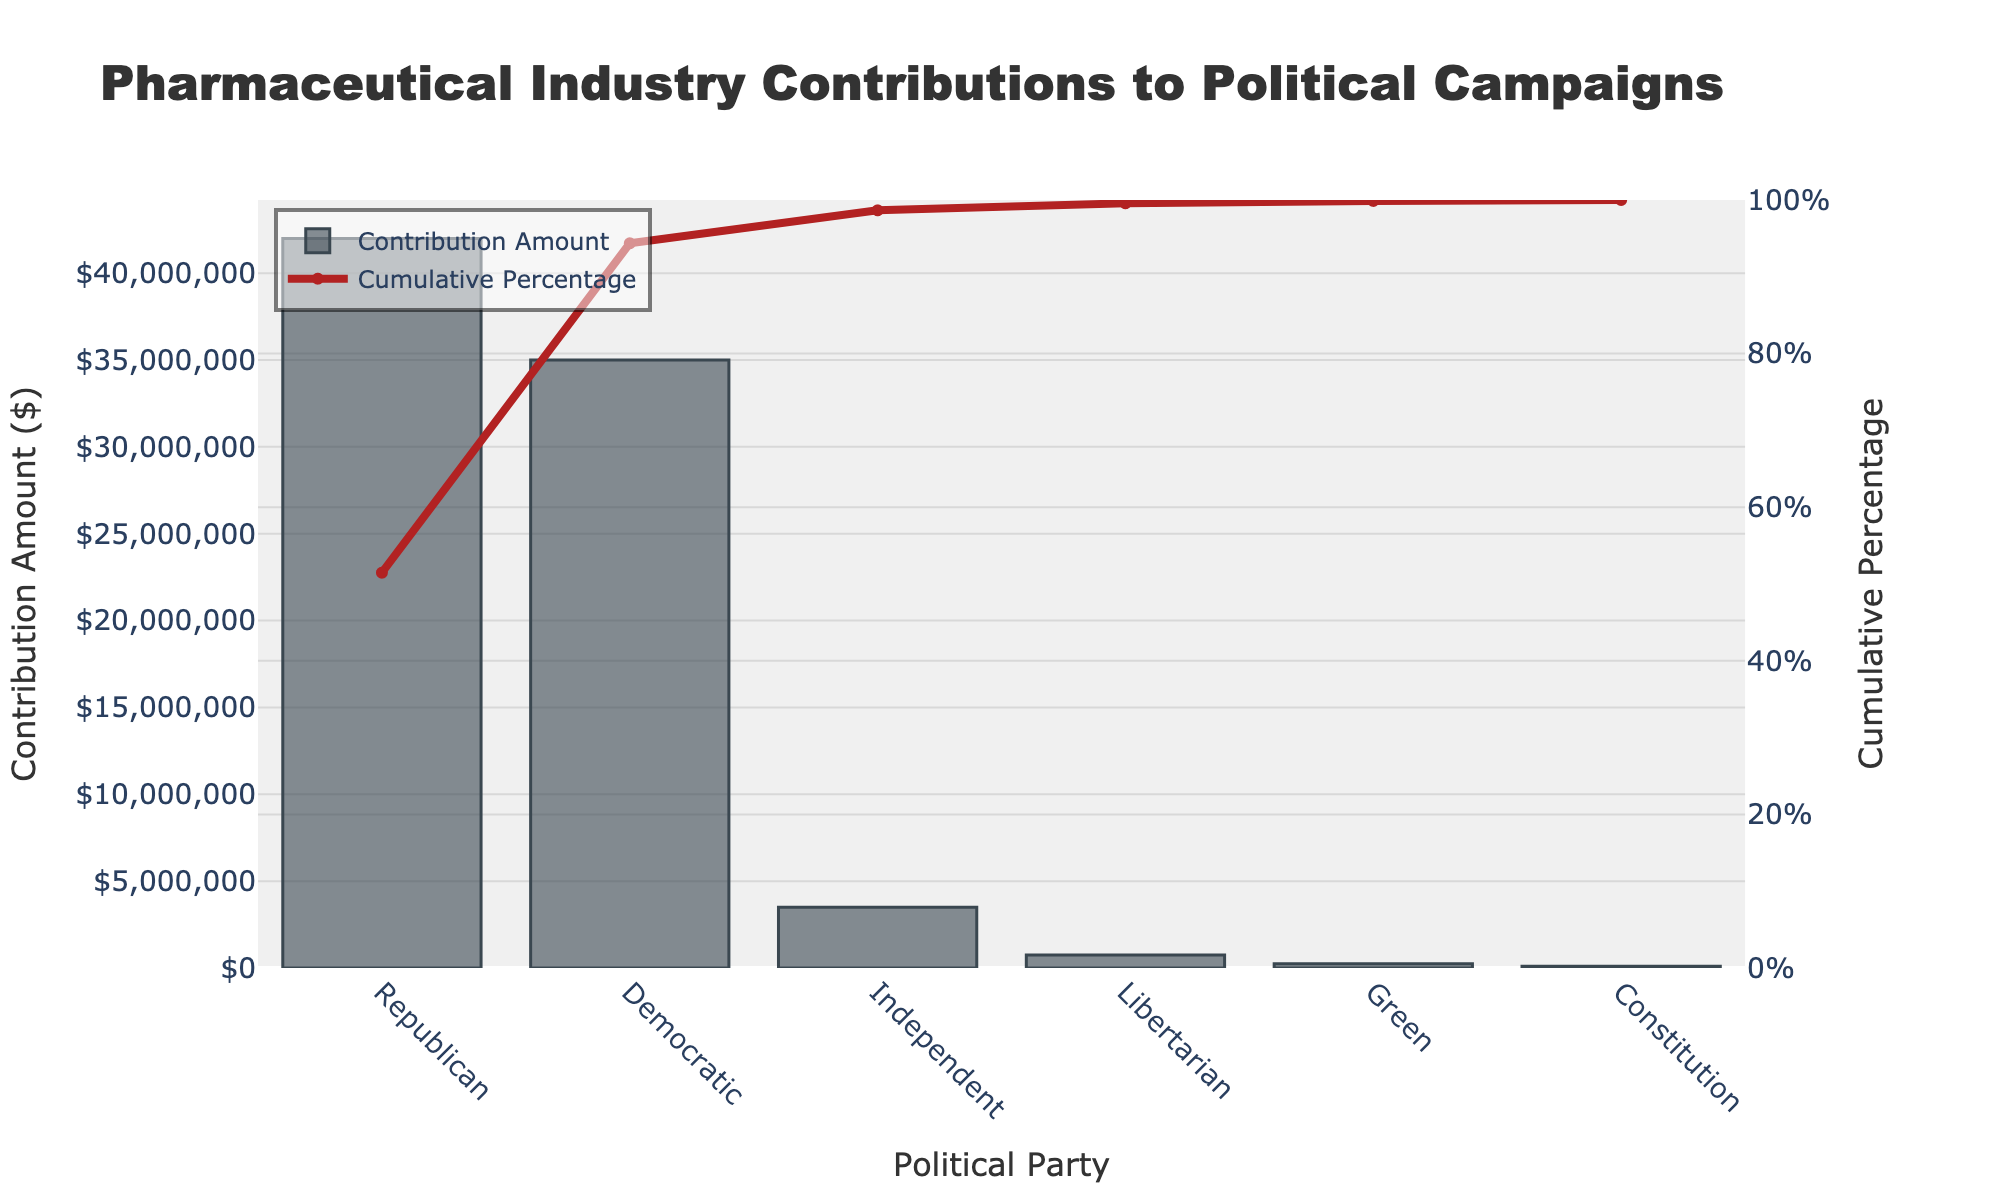What's the highest contribution amount by a political party? The highest bar in the Pareto chart represents the Republican party with the highest contribution amount.
Answer: Republican, $42,000,000 Which party has the lowest contribution amount? The smallest bar in the Pareto chart corresponds to the Constitution party with the lowest contribution amount.
Answer: Constitution, $100,000 What is the cumulative percentage of contributions after the Democratic party? The cumulative percentage line reaches 91.67% after the Democratic contribution amount, as the Democratic party's cumulative contribution follows immediately after the Republican party's contributions on the x-axis.
Answer: 91.67% How much more did Republicans receive compared to Independents? The Republican contributions are $42,000,000, and the Independent contributions are $3,500,000. Subtracting the two gives $42,000,000 - $3,500,000 = $38,500,000.
Answer: $38,500,000 What proportion of the total contributions did the Republican and Democratic parties collectively receive? The Republican and Democratic contributions are $42,000,000 and $35,000,000 respectively. Adding these together gives $42,000,000 + $35,000,000 = $77,000,000 total. The total contributions across all parties are $81,500,000. The proportion is $77,000,000 / $81,500,000 ≈ 94.48%.
Answer: Approximately 94.48% What is the cumulative percentage after three political parties? On the cumulative percentage line chart, the cumulative percent after the Republican, Democratic, and Independent parties adds up to a point between the third and fourth data points: $42,000,000 + $35,000,000 + $3,500,000 = $80,500,000. The total contribution is $81,500,000, so the cumulative percentage is ($80,500,000 / $81,500,000) * 100 ≈ 98.77%.
Answer: Approximately 98.77% Which party's contribution amount is closest to $1,000,000? The Libertarian party's contribution amount of $750,000 is closest to $1,000,000.
Answer: Libertarian What is the difference in cumulative percentage between the Libertarian and Green parties? The cumulative percentage for the Libertarian party is roughly 98.77%. The cumulative percentage after adding the Green party is roughly 99.08%. The difference is 99.08% - 98.77% = 0.31%.
Answer: 0.31% Is there any party that receives less than 1% of the total contributions? The total contributions are $81,500,000. Both the Green and Constitution parties receive $250,000 and $100,000 respectively, which are less than 1% of the total. ($250,000 / $81,500,000) * 100 ≈ 0.31% and ($100,000 / $81,500,000) * 100 ≈ 0.12%.
Answer: Yes, Green and Constitution parties 